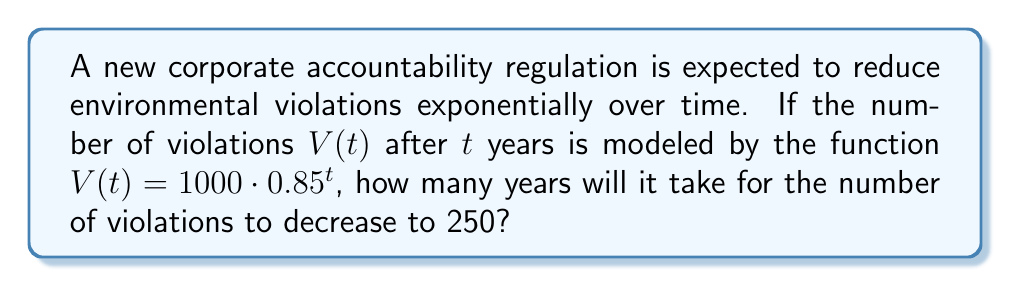Provide a solution to this math problem. To solve this problem, we need to use logarithms to isolate the variable $t$. Let's approach this step-by-step:

1) We start with the equation: $V(t) = 1000 \cdot 0.85^t$

2) We want to find $t$ when $V(t) = 250$, so we substitute this:

   $250 = 1000 \cdot 0.85^t$

3) Divide both sides by 1000:

   $\frac{250}{1000} = 0.85^t$

4) Simplify:

   $0.25 = 0.85^t$

5) Now, we need to take the logarithm of both sides. We can use any base, but it's convenient to use base 0.85 to cancel out on the right side:

   $\log_{0.85}(0.25) = \log_{0.85}(0.85^t)$

6) The right side simplifies to $t$ due to the logarithm rule $\log_a(a^x) = x$:

   $\log_{0.85}(0.25) = t$

7) To calculate this, we can use the change of base formula:

   $t = \frac{\log(0.25)}{\log(0.85)}$

8) Using a calculator (or computer):

   $t \approx 8.9657$

9) Since we're dealing with years, we need to round up to the next whole number.
Answer: 9 years 